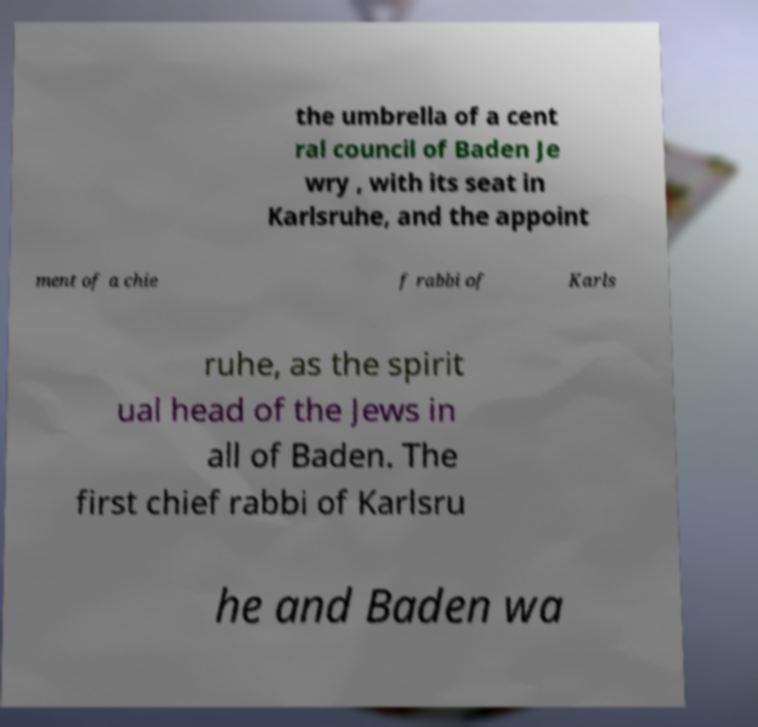Could you assist in decoding the text presented in this image and type it out clearly? the umbrella of a cent ral council of Baden Je wry , with its seat in Karlsruhe, and the appoint ment of a chie f rabbi of Karls ruhe, as the spirit ual head of the Jews in all of Baden. The first chief rabbi of Karlsru he and Baden wa 